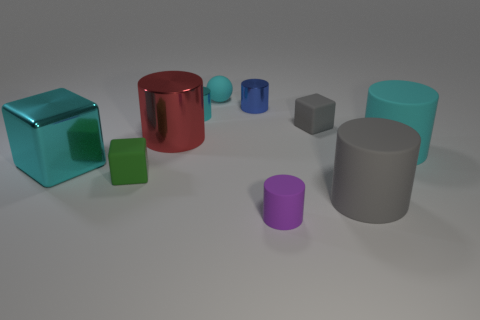Subtract 1 blocks. How many blocks are left? 2 Subtract all blue cylinders. How many cylinders are left? 5 Subtract all big shiny cylinders. How many cylinders are left? 5 Subtract all gray cylinders. Subtract all green cubes. How many cylinders are left? 5 Subtract all blocks. How many objects are left? 7 Add 7 tiny shiny cylinders. How many tiny shiny cylinders are left? 9 Add 3 large cyan metallic blocks. How many large cyan metallic blocks exist? 4 Subtract 0 red cubes. How many objects are left? 10 Subtract all big red things. Subtract all small cyan metal objects. How many objects are left? 8 